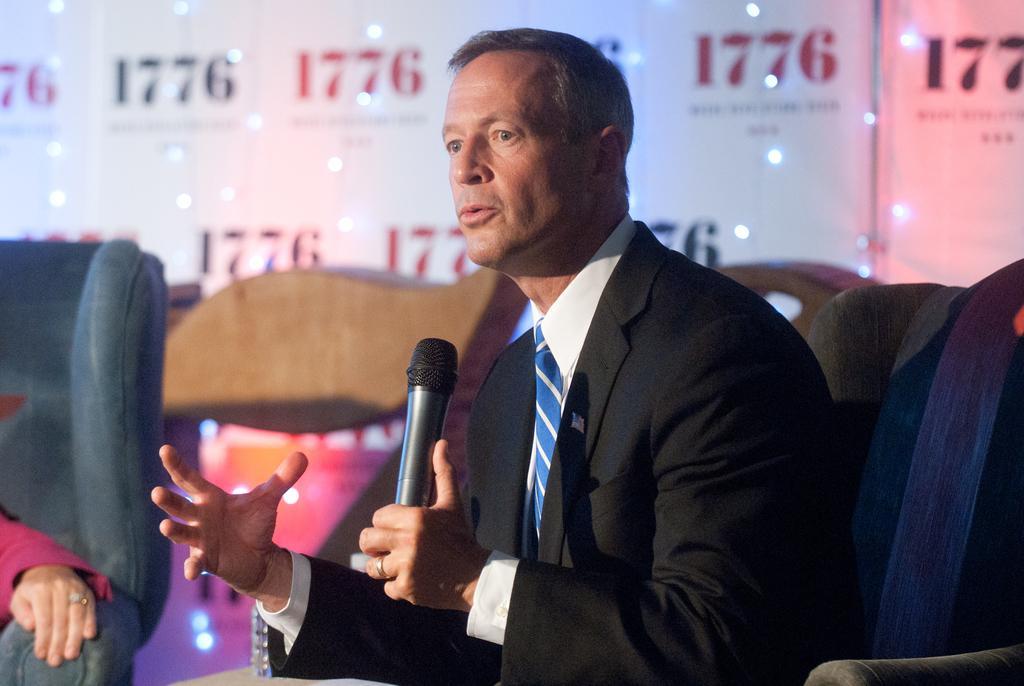In one or two sentences, can you explain what this image depicts? In this image there is a man sitting on a chair. He is holding a microphone in his hand. Behind him there is a board. There are numbers and lights on the board. To the left there is a hand of a person on the couch. 